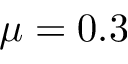Convert formula to latex. <formula><loc_0><loc_0><loc_500><loc_500>\mu = 0 . 3</formula> 